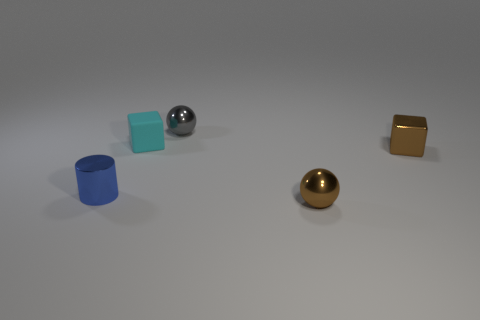Add 2 tiny gray objects. How many objects exist? 7 Subtract all cylinders. How many objects are left? 4 Add 2 tiny matte cubes. How many tiny matte cubes are left? 3 Add 5 small cyan rubber cubes. How many small cyan rubber cubes exist? 6 Subtract 0 red cubes. How many objects are left? 5 Subtract all small yellow rubber spheres. Subtract all small gray shiny balls. How many objects are left? 4 